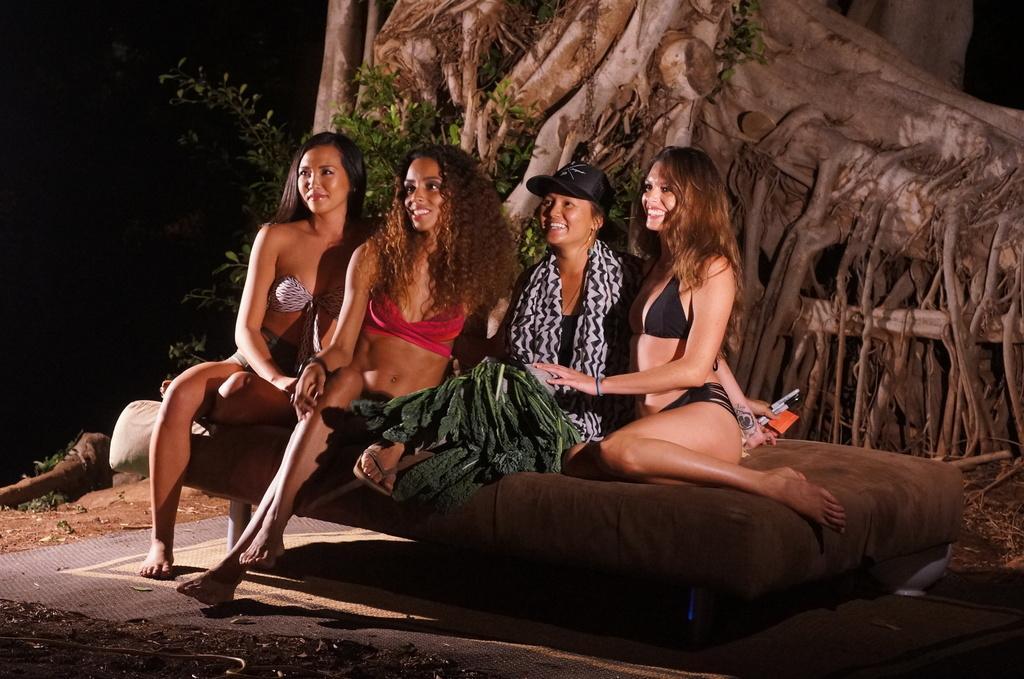Could you give a brief overview of what you see in this image? In this picture I can see, few woman seated on the bed and i can see a woman wore cap on the head and few trees on the back. 